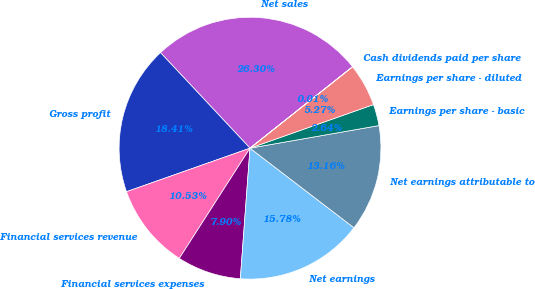<chart> <loc_0><loc_0><loc_500><loc_500><pie_chart><fcel>Net sales<fcel>Gross profit<fcel>Financial services revenue<fcel>Financial services expenses<fcel>Net earnings<fcel>Net earnings attributable to<fcel>Earnings per share - basic<fcel>Earnings per share - diluted<fcel>Cash dividends paid per share<nl><fcel>26.3%<fcel>18.41%<fcel>10.53%<fcel>7.9%<fcel>15.78%<fcel>13.16%<fcel>2.64%<fcel>5.27%<fcel>0.01%<nl></chart> 